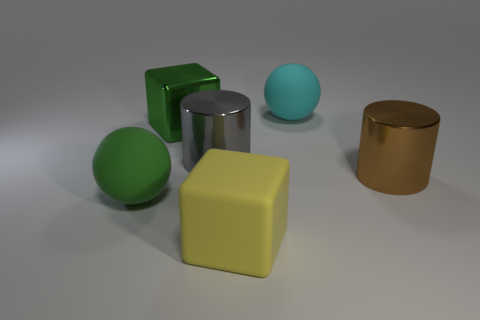Add 3 cyan balls. How many objects exist? 9 Subtract all cylinders. How many objects are left? 4 Add 2 green cubes. How many green cubes exist? 3 Subtract 1 green balls. How many objects are left? 5 Subtract all tiny brown spheres. Subtract all brown objects. How many objects are left? 5 Add 6 yellow matte things. How many yellow matte things are left? 7 